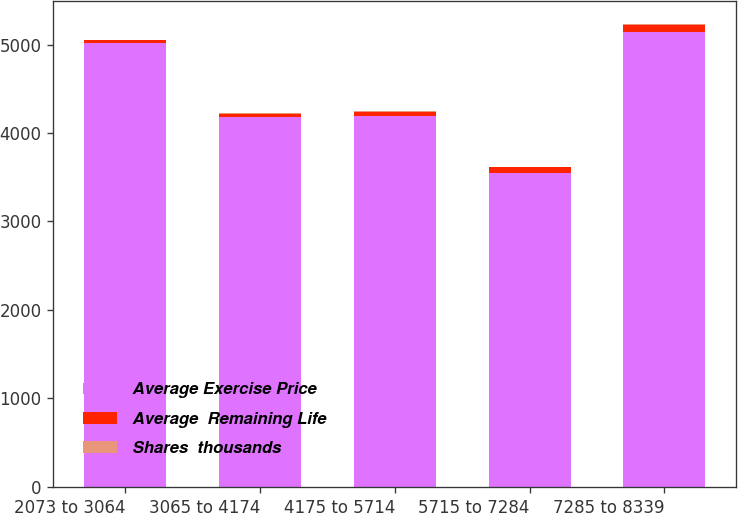Convert chart to OTSL. <chart><loc_0><loc_0><loc_500><loc_500><stacked_bar_chart><ecel><fcel>2073 to 3064<fcel>3065 to 4174<fcel>4175 to 5714<fcel>5715 to 7284<fcel>7285 to 8339<nl><fcel>Average Exercise Price<fcel>5022<fcel>4183<fcel>4187<fcel>3550<fcel>5142<nl><fcel>Average  Remaining Life<fcel>24.94<fcel>35.78<fcel>52.17<fcel>63.17<fcel>77.28<nl><fcel>Shares  thousands<fcel>2<fcel>4<fcel>6<fcel>8<fcel>9<nl></chart> 